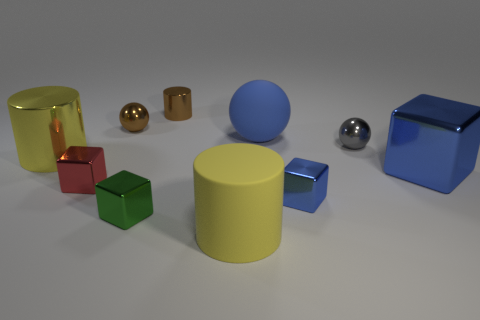Subtract all brown metallic spheres. How many spheres are left? 2 Subtract all blue cubes. How many cubes are left? 2 Subtract 1 green cubes. How many objects are left? 9 Subtract all cubes. How many objects are left? 6 Subtract 1 cylinders. How many cylinders are left? 2 Subtract all red cubes. Subtract all green cylinders. How many cubes are left? 3 Subtract all blue cylinders. How many blue blocks are left? 2 Subtract all small cyan metallic spheres. Subtract all small brown cylinders. How many objects are left? 9 Add 8 green cubes. How many green cubes are left? 9 Add 7 blue rubber objects. How many blue rubber objects exist? 8 